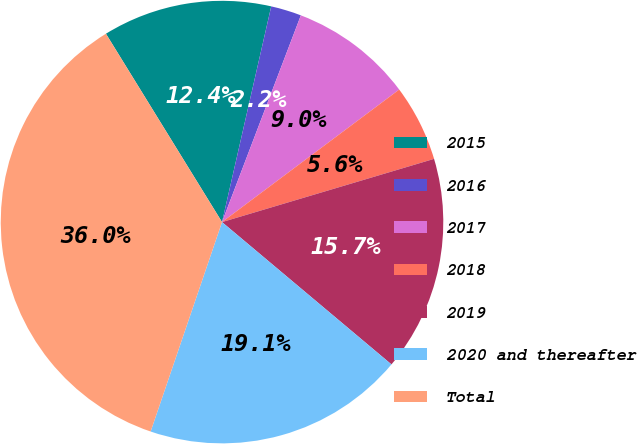<chart> <loc_0><loc_0><loc_500><loc_500><pie_chart><fcel>2015<fcel>2016<fcel>2017<fcel>2018<fcel>2019<fcel>2020 and thereafter<fcel>Total<nl><fcel>12.36%<fcel>2.23%<fcel>8.98%<fcel>5.61%<fcel>15.73%<fcel>19.11%<fcel>35.98%<nl></chart> 